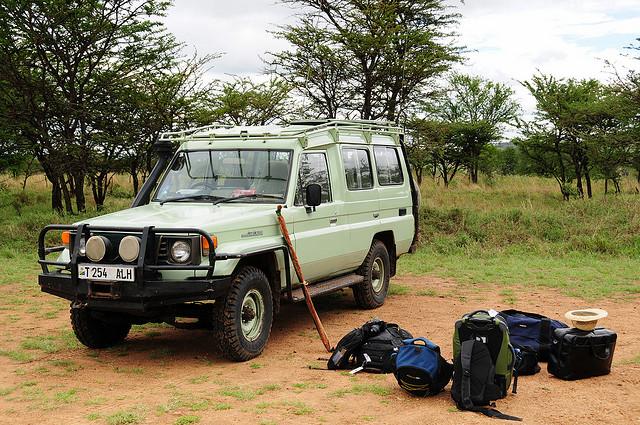What does the license plate say?
Keep it brief. T254. What is in front of the truck?
Write a very short answer. Nothing. Why is there luggage on the ground?
Quick response, please. Camping. What kind of vehicle is pictured here?
Be succinct. Suv. 